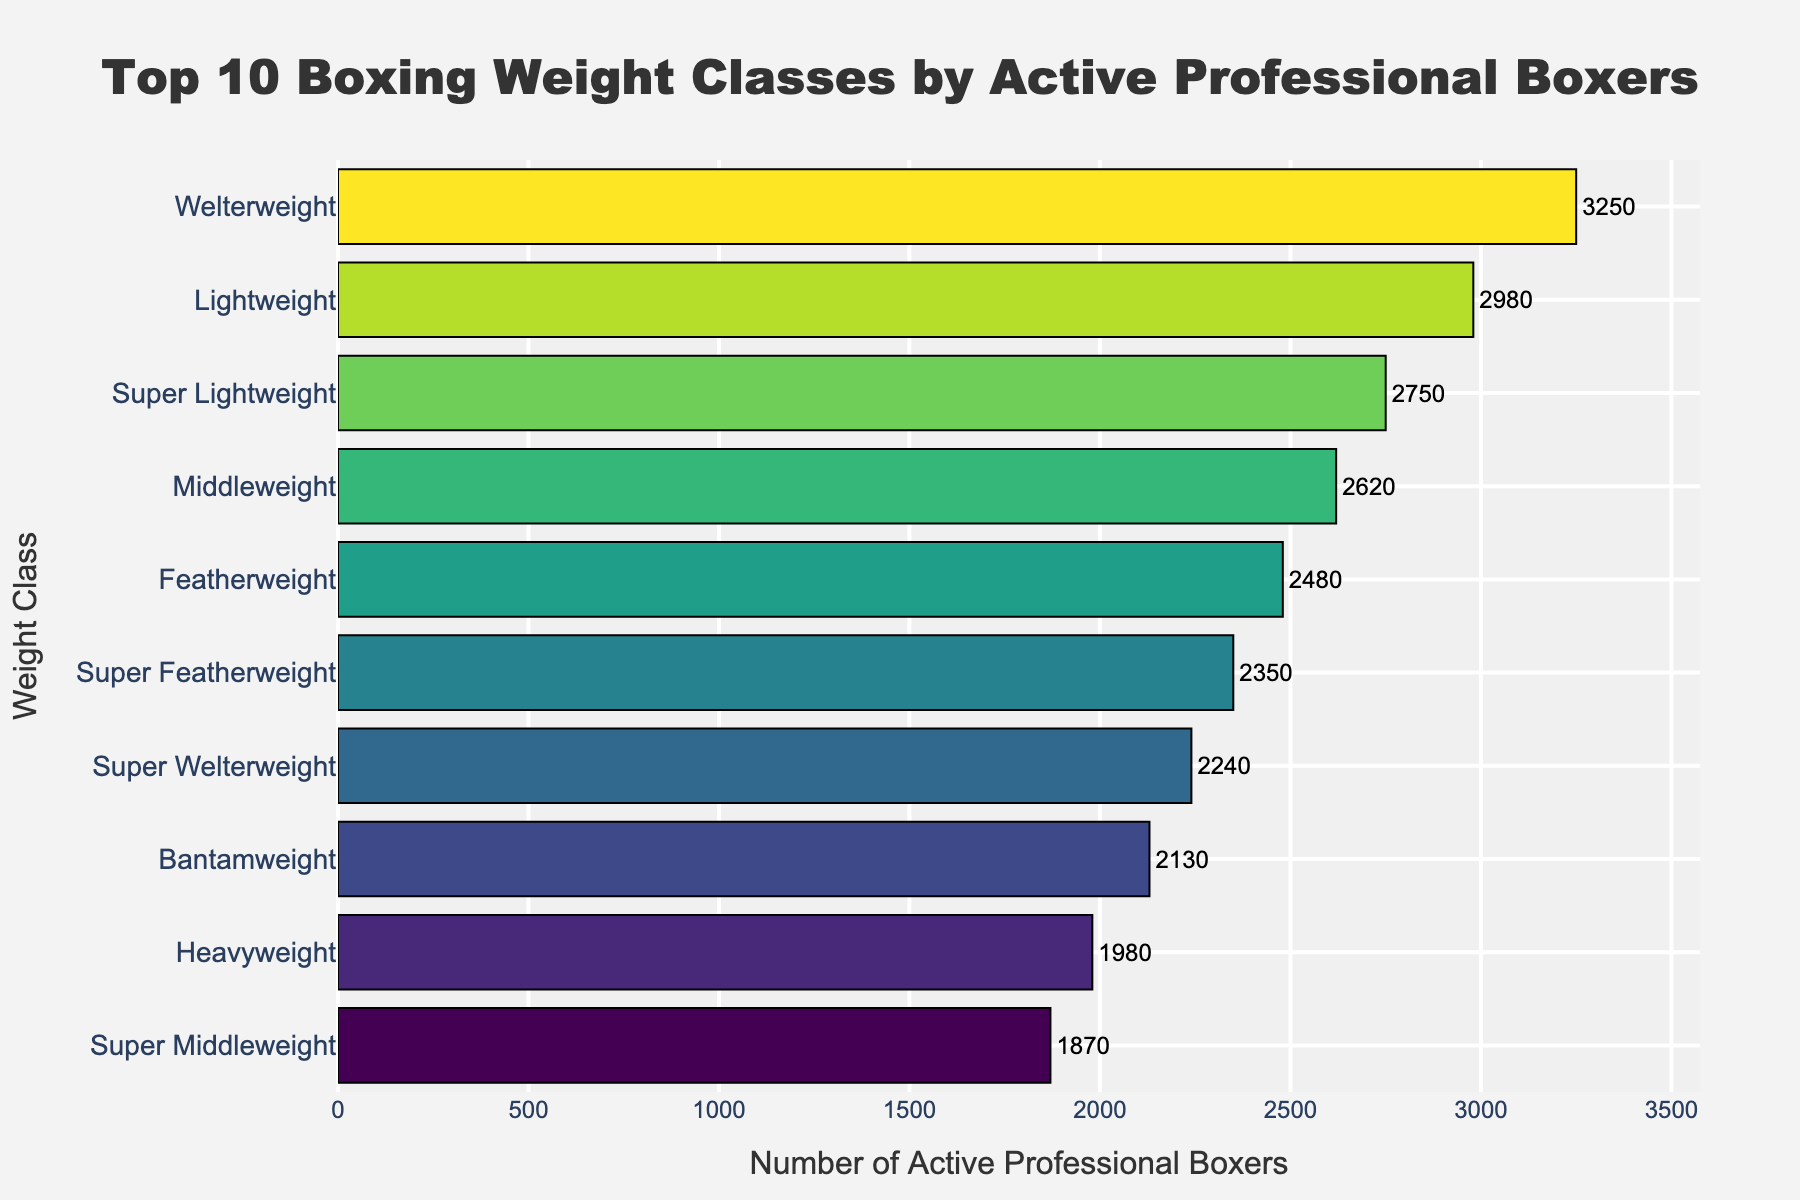Which weight class has the highest number of active professional boxers? The weight class with the highest number of active professional boxers is represented by the longest bar in the chart. The longest bar corresponds to the Welterweight class with 3250 active professional boxers.
Answer: Welterweight What is the combined number of active professional boxers in the Featherweight and Bantamweight classes? To find the combined number, add the number of active professional boxers in the Featherweight class (2480) and the Bantamweight class (2130). 2480 + 2130 = 4610.
Answer: 4610 Which weight classes have fewer than 2000 active professional boxers? Weight classes with fewer than 2000 active professional boxers are those with bars that fall below the 2000 mark on the x-axis. The Heavyweight class has 1980 boxers and the Super Middleweight class has 1870 boxers.
Answer: Heavyweight, Super Middleweight What is the difference between the number of active professional boxers in the Lightweight and Super Middleweight classes? To find the difference, subtract the number of active professional boxers in the Super Middleweight class (1870) from the Lightweight class (2980). 2980 - 1870 = 1110.
Answer: 1110 How many more active professional boxers are in the Welterweight class compared to the Featherweight class? Subtract the number of active professional boxers in the Featherweight class (2480) from the Welterweight class (3250). 3250 - 2480 = 770.
Answer: 770 Which weight class has nearly the same number of active professional boxers as the Middleweight class? Find the weight class with a number of boxers closest to the Middleweight class, which has 2620 boxers. The closest is the Super Lightweight class with 2750 boxers.
Answer: Super Lightweight List the weight classes in descending order by the number of active professional boxers. Sort the weight classes based on the number of active professional boxers from highest to lowest: Welterweight (3250), Lightweight (2980), Super Lightweight (2750), Middleweight (2620), Featherweight (2480), Super Featherweight (2350), Super Welterweight (2240), Bantamweight (2130), Heavyweight (1980), Super Middleweight (1870).
Answer: Welterweight, Lightweight, Super Lightweight, Middleweight, Featherweight, Super Featherweight, Super Welterweight, Bantamweight, Heavyweight, Super Middleweight What is the average number of active professional boxers in the top 5 weight classes? Sum the number of boxers in the top 5 classes: Welterweight (3250), Lightweight (2980), Super Lightweight (2750), Middleweight (2620), and Featherweight (2480). The total is 3250 + 2980 + 2750 + 2620 + 2480 = 14080. Divide by 5 to get the average: 14080 / 5 = 2816.
Answer: 2816 